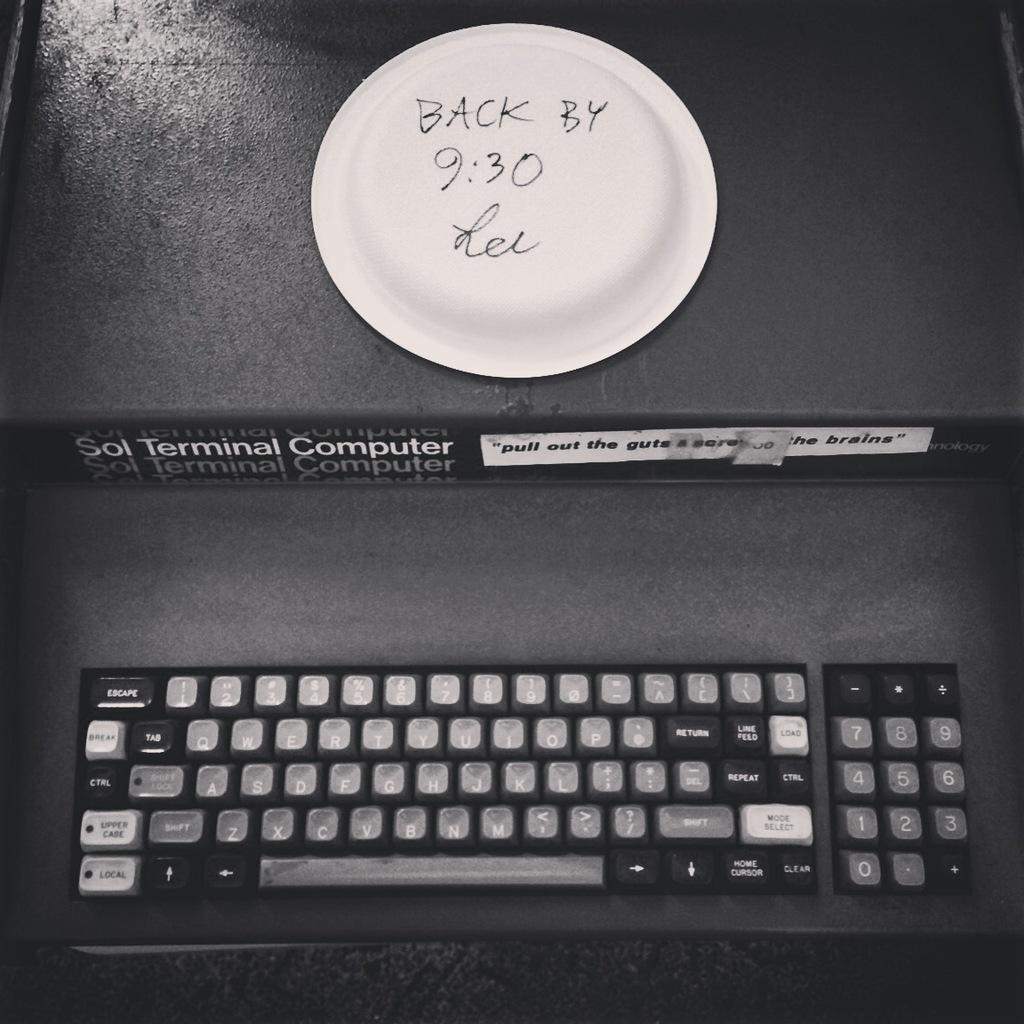What object is placed on a box in the image? There is a plate placed on a box in the image. What is the plate resting on? The plate is placed on a box in the image. What other object can be seen in the image? There is a keyboard in the image. Where is the keyboard located? The keyboard is placed on a table in the image. How many horses are visible in the image? There are no horses present in the image. What type of cracker is placed on the keyboard in the image? There is no cracker present on the keyboard or anywhere else in the image. 